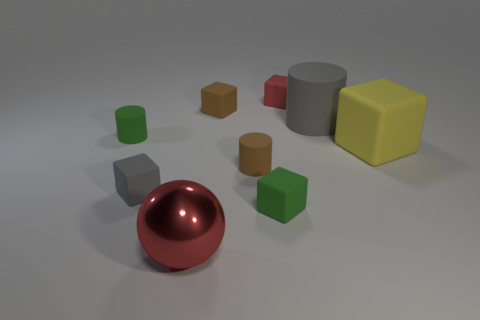What materials are represented in the objects shown in this image? The objects in the image display a variety of materials, with appearances suggesting some are made of matte finishes, like the cylinders and blocks, while the sphere has a reflective, almost metallic look, indicating a glossier material. 